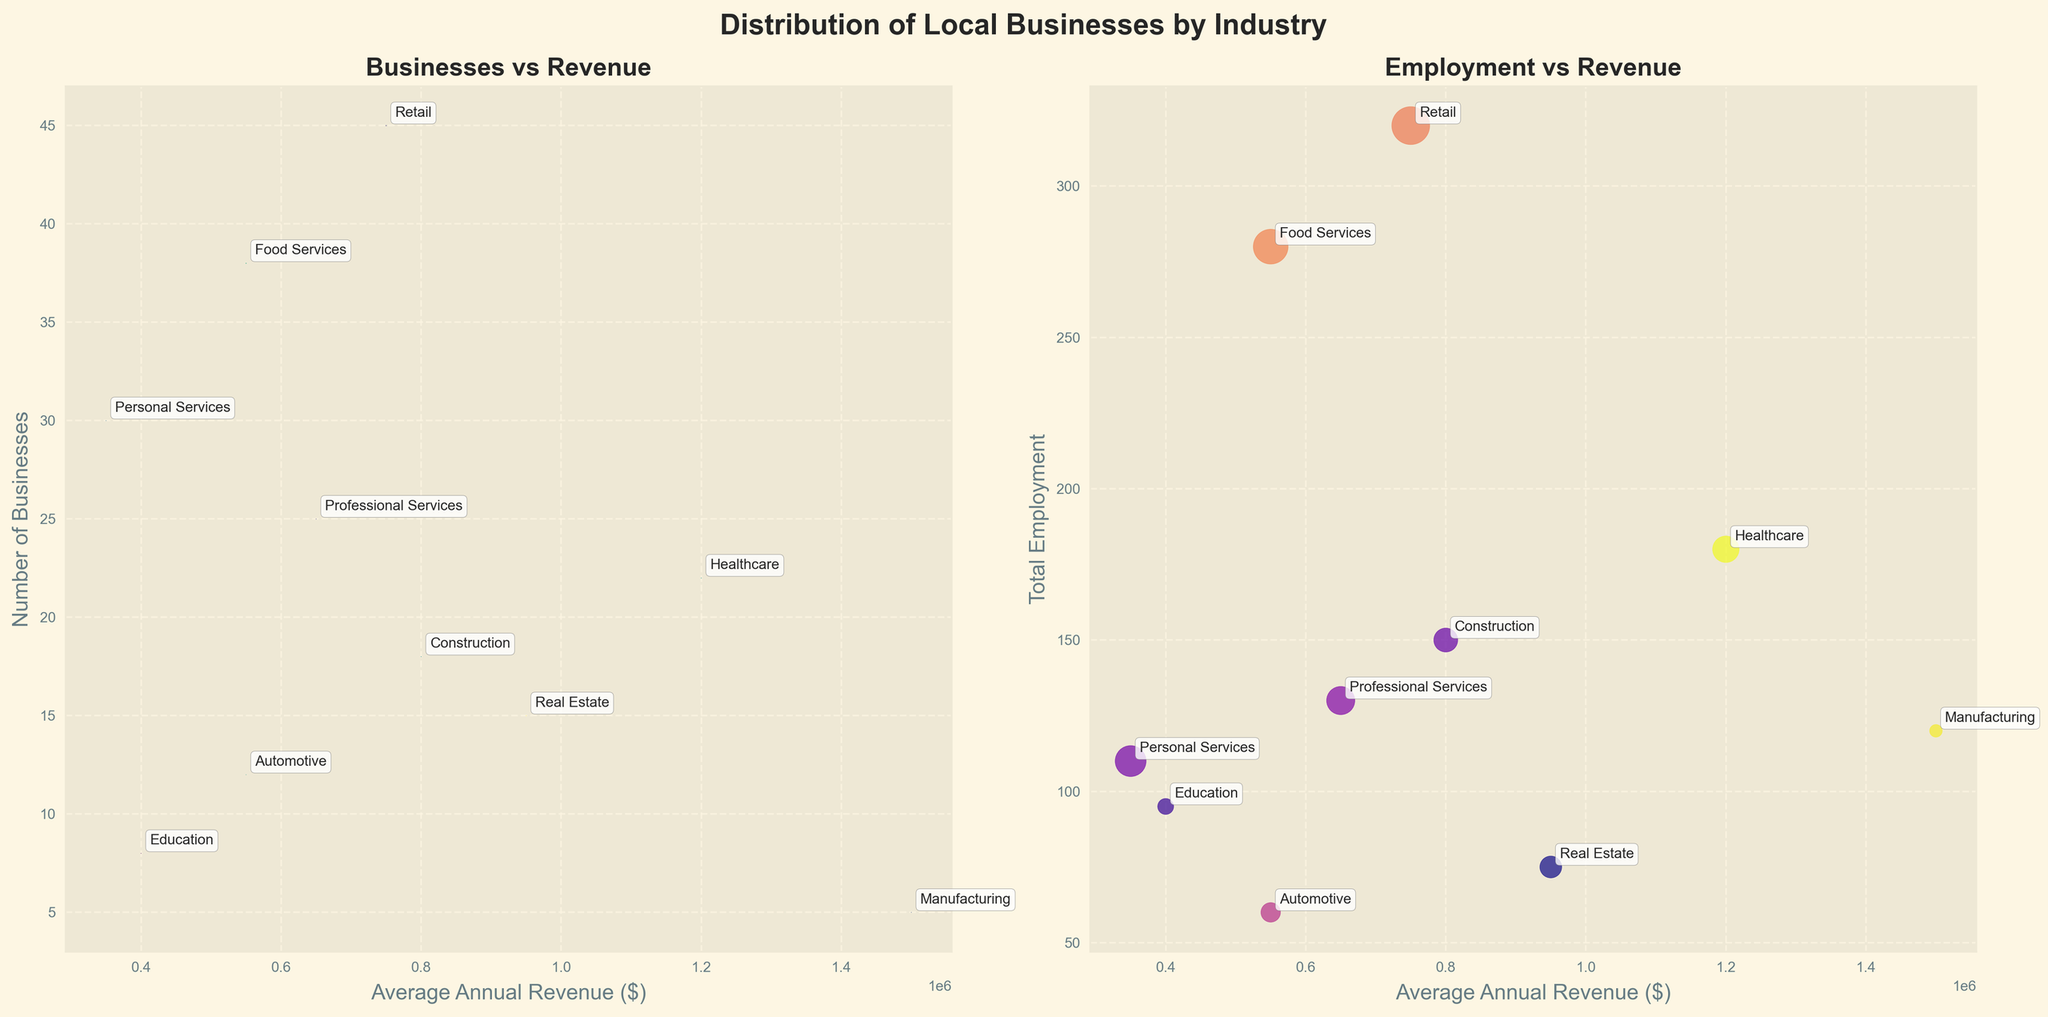What is the title of the figure? The title is displayed prominently at the top of the figure. It reads "Distribution of Local Businesses by Industry".
Answer: Distribution of Local Businesses by Industry Which industry has the highest average annual revenue? By looking at the X-axis values in the figure, Manufacturing has the highest average annual revenue, positioned at $1,500,000.
Answer: Manufacturing How many businesses are there in the Retail industry? The Y-axis of the first subplot shows the number of businesses, and the data point for Retail is annotated with "Retail", placed at 45.
Answer: 45 Which industry has the least number of businesses? By checking the Y-axis values of the first subplot, the Education industry has the least number of businesses, with 8 annotated as "Education".
Answer: Education Which industry employs the most people? The Y-axis of the second subplot shows the total employment, and the highest point, marked "Retail", is at 320.
Answer: Retail Compare the average annual revenue between Construction and Healthcare industries. By comparing the X-axis values in both subplots, Healthcare and Construction have revenues of $1,200,000 and $800,000, respectively. Healthcare's revenue is higher.
Answer: Healthcare What is the total number of businesses in the Retail and Food Services industries combined? The Retail industry has 45 businesses, and Food Services have 38. Adding these gives 45 + 38 = 83.
Answer: 83 Which industry has a higher total employment: Professional Services or Manufacturing? By checking the Y-axis values in the second subplot, Professional Services have a total employment of 130, and Manufacturing has 120. Professional Services employs more people.
Answer: Professional Services Which industry is represented by the largest bubble in the first subplot? The bubble size corresponds to total employment. The bubble for Retail, positioned at 320 employees, is the largest.
Answer: Retail What is the correlation between average annual revenue and total employment? Observing the second subplot, the general trend is that as average annual revenue increases, total employment varies but shows a clustering pattern rather than a clear linear relationship.
Answer: No clear correlation 